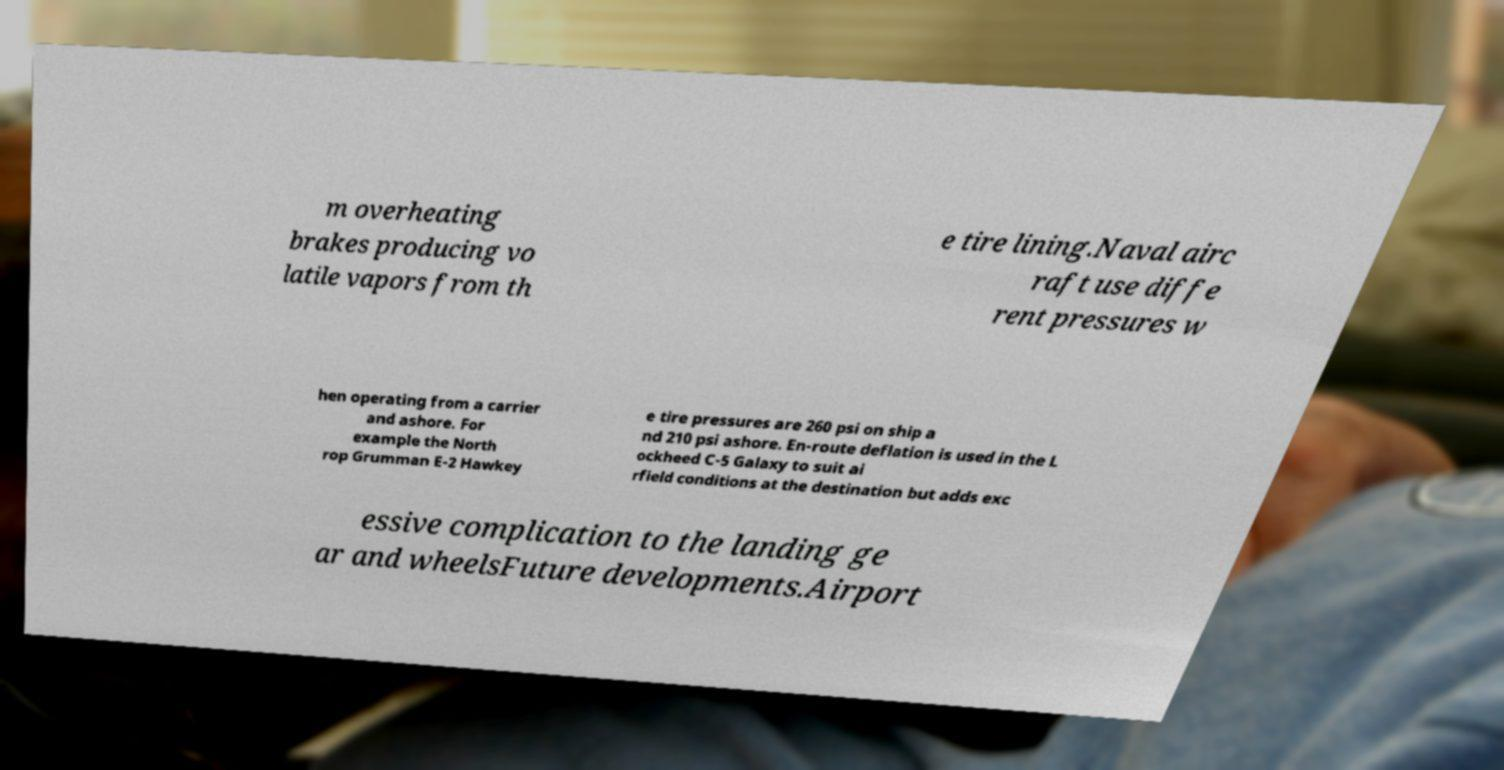Can you accurately transcribe the text from the provided image for me? m overheating brakes producing vo latile vapors from th e tire lining.Naval airc raft use diffe rent pressures w hen operating from a carrier and ashore. For example the North rop Grumman E-2 Hawkey e tire pressures are 260 psi on ship a nd 210 psi ashore. En-route deflation is used in the L ockheed C-5 Galaxy to suit ai rfield conditions at the destination but adds exc essive complication to the landing ge ar and wheelsFuture developments.Airport 